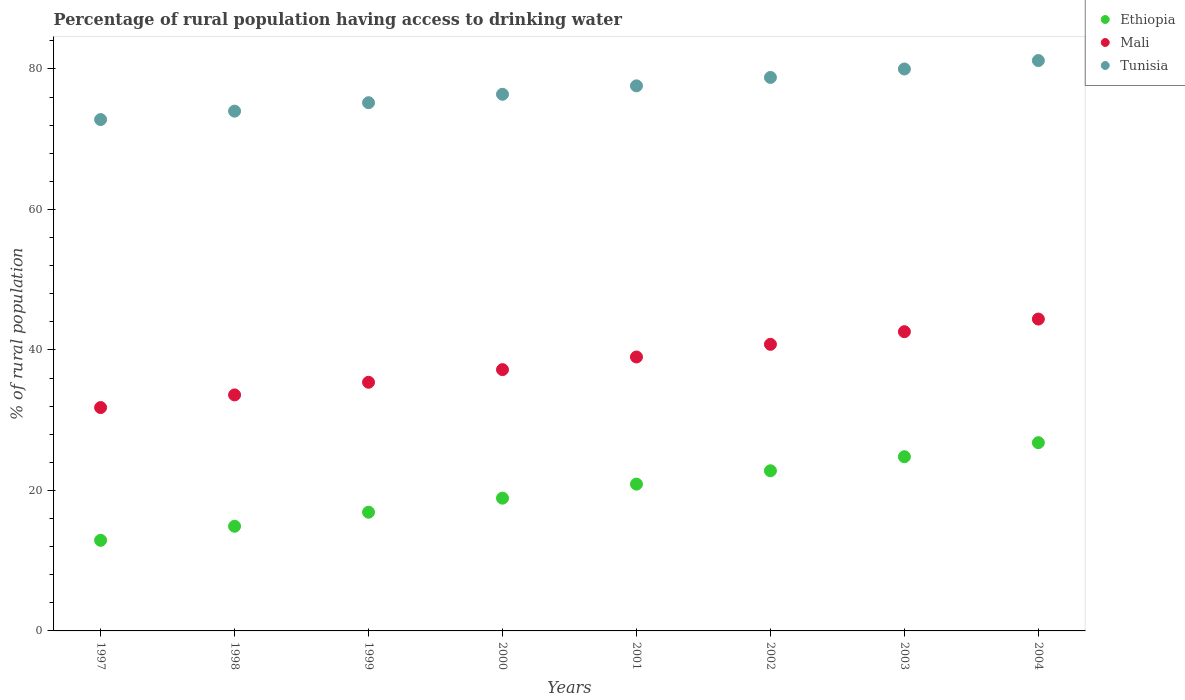Is the number of dotlines equal to the number of legend labels?
Your answer should be compact. Yes. Across all years, what is the maximum percentage of rural population having access to drinking water in Ethiopia?
Offer a very short reply. 26.8. In which year was the percentage of rural population having access to drinking water in Tunisia maximum?
Ensure brevity in your answer.  2004. What is the total percentage of rural population having access to drinking water in Ethiopia in the graph?
Keep it short and to the point. 158.9. What is the difference between the percentage of rural population having access to drinking water in Tunisia in 2001 and that in 2002?
Ensure brevity in your answer.  -1.2. What is the difference between the percentage of rural population having access to drinking water in Ethiopia in 2003 and the percentage of rural population having access to drinking water in Tunisia in 1999?
Make the answer very short. -50.4. What is the average percentage of rural population having access to drinking water in Ethiopia per year?
Your answer should be very brief. 19.86. In the year 2000, what is the difference between the percentage of rural population having access to drinking water in Tunisia and percentage of rural population having access to drinking water in Mali?
Make the answer very short. 39.2. What is the ratio of the percentage of rural population having access to drinking water in Mali in 1997 to that in 2002?
Offer a very short reply. 0.78. Is the difference between the percentage of rural population having access to drinking water in Tunisia in 1997 and 2002 greater than the difference between the percentage of rural population having access to drinking water in Mali in 1997 and 2002?
Keep it short and to the point. Yes. What is the difference between the highest and the second highest percentage of rural population having access to drinking water in Mali?
Offer a terse response. 1.8. What is the difference between the highest and the lowest percentage of rural population having access to drinking water in Mali?
Your answer should be compact. 12.6. Is it the case that in every year, the sum of the percentage of rural population having access to drinking water in Ethiopia and percentage of rural population having access to drinking water in Mali  is greater than the percentage of rural population having access to drinking water in Tunisia?
Your answer should be very brief. No. Is the percentage of rural population having access to drinking water in Tunisia strictly less than the percentage of rural population having access to drinking water in Mali over the years?
Ensure brevity in your answer.  No. How many dotlines are there?
Keep it short and to the point. 3. Does the graph contain any zero values?
Offer a terse response. No. Where does the legend appear in the graph?
Provide a short and direct response. Top right. What is the title of the graph?
Your answer should be compact. Percentage of rural population having access to drinking water. What is the label or title of the X-axis?
Ensure brevity in your answer.  Years. What is the label or title of the Y-axis?
Keep it short and to the point. % of rural population. What is the % of rural population in Ethiopia in 1997?
Offer a terse response. 12.9. What is the % of rural population in Mali in 1997?
Offer a very short reply. 31.8. What is the % of rural population of Tunisia in 1997?
Ensure brevity in your answer.  72.8. What is the % of rural population of Ethiopia in 1998?
Provide a succinct answer. 14.9. What is the % of rural population of Mali in 1998?
Provide a succinct answer. 33.6. What is the % of rural population of Tunisia in 1998?
Offer a very short reply. 74. What is the % of rural population of Ethiopia in 1999?
Provide a short and direct response. 16.9. What is the % of rural population of Mali in 1999?
Your response must be concise. 35.4. What is the % of rural population of Tunisia in 1999?
Keep it short and to the point. 75.2. What is the % of rural population in Mali in 2000?
Your answer should be compact. 37.2. What is the % of rural population of Tunisia in 2000?
Provide a succinct answer. 76.4. What is the % of rural population in Ethiopia in 2001?
Provide a short and direct response. 20.9. What is the % of rural population of Mali in 2001?
Ensure brevity in your answer.  39. What is the % of rural population of Tunisia in 2001?
Your answer should be compact. 77.6. What is the % of rural population of Ethiopia in 2002?
Ensure brevity in your answer.  22.8. What is the % of rural population in Mali in 2002?
Offer a very short reply. 40.8. What is the % of rural population of Tunisia in 2002?
Give a very brief answer. 78.8. What is the % of rural population in Ethiopia in 2003?
Provide a succinct answer. 24.8. What is the % of rural population of Mali in 2003?
Give a very brief answer. 42.6. What is the % of rural population of Tunisia in 2003?
Your response must be concise. 80. What is the % of rural population of Ethiopia in 2004?
Your response must be concise. 26.8. What is the % of rural population in Mali in 2004?
Give a very brief answer. 44.4. What is the % of rural population in Tunisia in 2004?
Keep it short and to the point. 81.2. Across all years, what is the maximum % of rural population in Ethiopia?
Your answer should be very brief. 26.8. Across all years, what is the maximum % of rural population of Mali?
Provide a short and direct response. 44.4. Across all years, what is the maximum % of rural population of Tunisia?
Give a very brief answer. 81.2. Across all years, what is the minimum % of rural population of Ethiopia?
Offer a very short reply. 12.9. Across all years, what is the minimum % of rural population of Mali?
Offer a terse response. 31.8. Across all years, what is the minimum % of rural population in Tunisia?
Ensure brevity in your answer.  72.8. What is the total % of rural population of Ethiopia in the graph?
Give a very brief answer. 158.9. What is the total % of rural population in Mali in the graph?
Make the answer very short. 304.8. What is the total % of rural population of Tunisia in the graph?
Your answer should be compact. 616. What is the difference between the % of rural population in Tunisia in 1997 and that in 1998?
Your response must be concise. -1.2. What is the difference between the % of rural population in Ethiopia in 1997 and that in 1999?
Your answer should be very brief. -4. What is the difference between the % of rural population of Ethiopia in 1997 and that in 2000?
Make the answer very short. -6. What is the difference between the % of rural population in Tunisia in 1997 and that in 2000?
Your answer should be very brief. -3.6. What is the difference between the % of rural population of Ethiopia in 1997 and that in 2001?
Your answer should be compact. -8. What is the difference between the % of rural population of Ethiopia in 1997 and that in 2002?
Keep it short and to the point. -9.9. What is the difference between the % of rural population in Tunisia in 1997 and that in 2002?
Provide a succinct answer. -6. What is the difference between the % of rural population of Mali in 1997 and that in 2003?
Your answer should be compact. -10.8. What is the difference between the % of rural population of Tunisia in 1997 and that in 2003?
Your response must be concise. -7.2. What is the difference between the % of rural population of Ethiopia in 1997 and that in 2004?
Your answer should be compact. -13.9. What is the difference between the % of rural population of Ethiopia in 1998 and that in 1999?
Offer a very short reply. -2. What is the difference between the % of rural population of Mali in 1998 and that in 1999?
Offer a terse response. -1.8. What is the difference between the % of rural population in Mali in 1998 and that in 2000?
Offer a terse response. -3.6. What is the difference between the % of rural population in Ethiopia in 1998 and that in 2001?
Keep it short and to the point. -6. What is the difference between the % of rural population in Mali in 1998 and that in 2001?
Your answer should be compact. -5.4. What is the difference between the % of rural population in Ethiopia in 1998 and that in 2002?
Your response must be concise. -7.9. What is the difference between the % of rural population in Mali in 1998 and that in 2002?
Your response must be concise. -7.2. What is the difference between the % of rural population of Mali in 1998 and that in 2003?
Your answer should be very brief. -9. What is the difference between the % of rural population in Tunisia in 1998 and that in 2004?
Make the answer very short. -7.2. What is the difference between the % of rural population of Ethiopia in 1999 and that in 2000?
Keep it short and to the point. -2. What is the difference between the % of rural population of Mali in 1999 and that in 2000?
Offer a terse response. -1.8. What is the difference between the % of rural population in Ethiopia in 1999 and that in 2001?
Your answer should be very brief. -4. What is the difference between the % of rural population of Tunisia in 1999 and that in 2002?
Offer a very short reply. -3.6. What is the difference between the % of rural population of Ethiopia in 1999 and that in 2003?
Provide a succinct answer. -7.9. What is the difference between the % of rural population of Mali in 1999 and that in 2003?
Give a very brief answer. -7.2. What is the difference between the % of rural population in Ethiopia in 2000 and that in 2001?
Ensure brevity in your answer.  -2. What is the difference between the % of rural population of Mali in 2000 and that in 2001?
Your answer should be very brief. -1.8. What is the difference between the % of rural population in Tunisia in 2000 and that in 2001?
Ensure brevity in your answer.  -1.2. What is the difference between the % of rural population in Ethiopia in 2000 and that in 2002?
Provide a short and direct response. -3.9. What is the difference between the % of rural population of Tunisia in 2000 and that in 2002?
Your answer should be very brief. -2.4. What is the difference between the % of rural population of Mali in 2000 and that in 2003?
Your answer should be very brief. -5.4. What is the difference between the % of rural population of Mali in 2000 and that in 2004?
Your response must be concise. -7.2. What is the difference between the % of rural population of Mali in 2001 and that in 2002?
Keep it short and to the point. -1.8. What is the difference between the % of rural population in Tunisia in 2001 and that in 2002?
Ensure brevity in your answer.  -1.2. What is the difference between the % of rural population of Mali in 2001 and that in 2003?
Make the answer very short. -3.6. What is the difference between the % of rural population in Tunisia in 2001 and that in 2003?
Your response must be concise. -2.4. What is the difference between the % of rural population in Ethiopia in 2001 and that in 2004?
Your response must be concise. -5.9. What is the difference between the % of rural population in Mali in 2001 and that in 2004?
Make the answer very short. -5.4. What is the difference between the % of rural population of Ethiopia in 2002 and that in 2003?
Provide a short and direct response. -2. What is the difference between the % of rural population of Tunisia in 2002 and that in 2003?
Keep it short and to the point. -1.2. What is the difference between the % of rural population of Mali in 2002 and that in 2004?
Provide a succinct answer. -3.6. What is the difference between the % of rural population of Mali in 2003 and that in 2004?
Your response must be concise. -1.8. What is the difference between the % of rural population of Tunisia in 2003 and that in 2004?
Keep it short and to the point. -1.2. What is the difference between the % of rural population of Ethiopia in 1997 and the % of rural population of Mali in 1998?
Make the answer very short. -20.7. What is the difference between the % of rural population of Ethiopia in 1997 and the % of rural population of Tunisia in 1998?
Ensure brevity in your answer.  -61.1. What is the difference between the % of rural population in Mali in 1997 and the % of rural population in Tunisia in 1998?
Your answer should be very brief. -42.2. What is the difference between the % of rural population in Ethiopia in 1997 and the % of rural population in Mali in 1999?
Ensure brevity in your answer.  -22.5. What is the difference between the % of rural population in Ethiopia in 1997 and the % of rural population in Tunisia in 1999?
Provide a short and direct response. -62.3. What is the difference between the % of rural population of Mali in 1997 and the % of rural population of Tunisia in 1999?
Provide a short and direct response. -43.4. What is the difference between the % of rural population of Ethiopia in 1997 and the % of rural population of Mali in 2000?
Provide a succinct answer. -24.3. What is the difference between the % of rural population in Ethiopia in 1997 and the % of rural population in Tunisia in 2000?
Keep it short and to the point. -63.5. What is the difference between the % of rural population of Mali in 1997 and the % of rural population of Tunisia in 2000?
Your answer should be very brief. -44.6. What is the difference between the % of rural population of Ethiopia in 1997 and the % of rural population of Mali in 2001?
Your answer should be very brief. -26.1. What is the difference between the % of rural population of Ethiopia in 1997 and the % of rural population of Tunisia in 2001?
Offer a terse response. -64.7. What is the difference between the % of rural population of Mali in 1997 and the % of rural population of Tunisia in 2001?
Your answer should be very brief. -45.8. What is the difference between the % of rural population in Ethiopia in 1997 and the % of rural population in Mali in 2002?
Give a very brief answer. -27.9. What is the difference between the % of rural population in Ethiopia in 1997 and the % of rural population in Tunisia in 2002?
Keep it short and to the point. -65.9. What is the difference between the % of rural population in Mali in 1997 and the % of rural population in Tunisia in 2002?
Give a very brief answer. -47. What is the difference between the % of rural population of Ethiopia in 1997 and the % of rural population of Mali in 2003?
Make the answer very short. -29.7. What is the difference between the % of rural population of Ethiopia in 1997 and the % of rural population of Tunisia in 2003?
Offer a terse response. -67.1. What is the difference between the % of rural population of Mali in 1997 and the % of rural population of Tunisia in 2003?
Offer a very short reply. -48.2. What is the difference between the % of rural population in Ethiopia in 1997 and the % of rural population in Mali in 2004?
Give a very brief answer. -31.5. What is the difference between the % of rural population of Ethiopia in 1997 and the % of rural population of Tunisia in 2004?
Keep it short and to the point. -68.3. What is the difference between the % of rural population in Mali in 1997 and the % of rural population in Tunisia in 2004?
Your answer should be compact. -49.4. What is the difference between the % of rural population in Ethiopia in 1998 and the % of rural population in Mali in 1999?
Keep it short and to the point. -20.5. What is the difference between the % of rural population in Ethiopia in 1998 and the % of rural population in Tunisia in 1999?
Your response must be concise. -60.3. What is the difference between the % of rural population in Mali in 1998 and the % of rural population in Tunisia in 1999?
Keep it short and to the point. -41.6. What is the difference between the % of rural population of Ethiopia in 1998 and the % of rural population of Mali in 2000?
Your answer should be compact. -22.3. What is the difference between the % of rural population of Ethiopia in 1998 and the % of rural population of Tunisia in 2000?
Your response must be concise. -61.5. What is the difference between the % of rural population in Mali in 1998 and the % of rural population in Tunisia in 2000?
Offer a very short reply. -42.8. What is the difference between the % of rural population in Ethiopia in 1998 and the % of rural population in Mali in 2001?
Make the answer very short. -24.1. What is the difference between the % of rural population in Ethiopia in 1998 and the % of rural population in Tunisia in 2001?
Provide a succinct answer. -62.7. What is the difference between the % of rural population of Mali in 1998 and the % of rural population of Tunisia in 2001?
Make the answer very short. -44. What is the difference between the % of rural population in Ethiopia in 1998 and the % of rural population in Mali in 2002?
Your answer should be compact. -25.9. What is the difference between the % of rural population in Ethiopia in 1998 and the % of rural population in Tunisia in 2002?
Provide a succinct answer. -63.9. What is the difference between the % of rural population in Mali in 1998 and the % of rural population in Tunisia in 2002?
Provide a succinct answer. -45.2. What is the difference between the % of rural population of Ethiopia in 1998 and the % of rural population of Mali in 2003?
Offer a terse response. -27.7. What is the difference between the % of rural population in Ethiopia in 1998 and the % of rural population in Tunisia in 2003?
Your answer should be very brief. -65.1. What is the difference between the % of rural population in Mali in 1998 and the % of rural population in Tunisia in 2003?
Offer a very short reply. -46.4. What is the difference between the % of rural population of Ethiopia in 1998 and the % of rural population of Mali in 2004?
Offer a terse response. -29.5. What is the difference between the % of rural population of Ethiopia in 1998 and the % of rural population of Tunisia in 2004?
Your response must be concise. -66.3. What is the difference between the % of rural population of Mali in 1998 and the % of rural population of Tunisia in 2004?
Your response must be concise. -47.6. What is the difference between the % of rural population of Ethiopia in 1999 and the % of rural population of Mali in 2000?
Keep it short and to the point. -20.3. What is the difference between the % of rural population of Ethiopia in 1999 and the % of rural population of Tunisia in 2000?
Offer a terse response. -59.5. What is the difference between the % of rural population of Mali in 1999 and the % of rural population of Tunisia in 2000?
Provide a succinct answer. -41. What is the difference between the % of rural population in Ethiopia in 1999 and the % of rural population in Mali in 2001?
Ensure brevity in your answer.  -22.1. What is the difference between the % of rural population in Ethiopia in 1999 and the % of rural population in Tunisia in 2001?
Your answer should be compact. -60.7. What is the difference between the % of rural population of Mali in 1999 and the % of rural population of Tunisia in 2001?
Provide a succinct answer. -42.2. What is the difference between the % of rural population in Ethiopia in 1999 and the % of rural population in Mali in 2002?
Your answer should be very brief. -23.9. What is the difference between the % of rural population of Ethiopia in 1999 and the % of rural population of Tunisia in 2002?
Your answer should be compact. -61.9. What is the difference between the % of rural population in Mali in 1999 and the % of rural population in Tunisia in 2002?
Offer a very short reply. -43.4. What is the difference between the % of rural population in Ethiopia in 1999 and the % of rural population in Mali in 2003?
Offer a very short reply. -25.7. What is the difference between the % of rural population of Ethiopia in 1999 and the % of rural population of Tunisia in 2003?
Provide a succinct answer. -63.1. What is the difference between the % of rural population in Mali in 1999 and the % of rural population in Tunisia in 2003?
Your answer should be compact. -44.6. What is the difference between the % of rural population of Ethiopia in 1999 and the % of rural population of Mali in 2004?
Offer a very short reply. -27.5. What is the difference between the % of rural population of Ethiopia in 1999 and the % of rural population of Tunisia in 2004?
Offer a terse response. -64.3. What is the difference between the % of rural population of Mali in 1999 and the % of rural population of Tunisia in 2004?
Provide a short and direct response. -45.8. What is the difference between the % of rural population in Ethiopia in 2000 and the % of rural population in Mali in 2001?
Offer a very short reply. -20.1. What is the difference between the % of rural population of Ethiopia in 2000 and the % of rural population of Tunisia in 2001?
Offer a very short reply. -58.7. What is the difference between the % of rural population of Mali in 2000 and the % of rural population of Tunisia in 2001?
Your answer should be compact. -40.4. What is the difference between the % of rural population of Ethiopia in 2000 and the % of rural population of Mali in 2002?
Your answer should be very brief. -21.9. What is the difference between the % of rural population of Ethiopia in 2000 and the % of rural population of Tunisia in 2002?
Provide a succinct answer. -59.9. What is the difference between the % of rural population of Mali in 2000 and the % of rural population of Tunisia in 2002?
Offer a terse response. -41.6. What is the difference between the % of rural population of Ethiopia in 2000 and the % of rural population of Mali in 2003?
Your answer should be compact. -23.7. What is the difference between the % of rural population in Ethiopia in 2000 and the % of rural population in Tunisia in 2003?
Offer a very short reply. -61.1. What is the difference between the % of rural population of Mali in 2000 and the % of rural population of Tunisia in 2003?
Provide a succinct answer. -42.8. What is the difference between the % of rural population in Ethiopia in 2000 and the % of rural population in Mali in 2004?
Offer a terse response. -25.5. What is the difference between the % of rural population of Ethiopia in 2000 and the % of rural population of Tunisia in 2004?
Give a very brief answer. -62.3. What is the difference between the % of rural population in Mali in 2000 and the % of rural population in Tunisia in 2004?
Give a very brief answer. -44. What is the difference between the % of rural population of Ethiopia in 2001 and the % of rural population of Mali in 2002?
Provide a succinct answer. -19.9. What is the difference between the % of rural population of Ethiopia in 2001 and the % of rural population of Tunisia in 2002?
Keep it short and to the point. -57.9. What is the difference between the % of rural population in Mali in 2001 and the % of rural population in Tunisia in 2002?
Keep it short and to the point. -39.8. What is the difference between the % of rural population of Ethiopia in 2001 and the % of rural population of Mali in 2003?
Give a very brief answer. -21.7. What is the difference between the % of rural population in Ethiopia in 2001 and the % of rural population in Tunisia in 2003?
Offer a terse response. -59.1. What is the difference between the % of rural population in Mali in 2001 and the % of rural population in Tunisia in 2003?
Offer a terse response. -41. What is the difference between the % of rural population in Ethiopia in 2001 and the % of rural population in Mali in 2004?
Give a very brief answer. -23.5. What is the difference between the % of rural population in Ethiopia in 2001 and the % of rural population in Tunisia in 2004?
Provide a succinct answer. -60.3. What is the difference between the % of rural population of Mali in 2001 and the % of rural population of Tunisia in 2004?
Your response must be concise. -42.2. What is the difference between the % of rural population in Ethiopia in 2002 and the % of rural population in Mali in 2003?
Offer a very short reply. -19.8. What is the difference between the % of rural population in Ethiopia in 2002 and the % of rural population in Tunisia in 2003?
Your answer should be compact. -57.2. What is the difference between the % of rural population in Mali in 2002 and the % of rural population in Tunisia in 2003?
Your answer should be compact. -39.2. What is the difference between the % of rural population of Ethiopia in 2002 and the % of rural population of Mali in 2004?
Offer a terse response. -21.6. What is the difference between the % of rural population in Ethiopia in 2002 and the % of rural population in Tunisia in 2004?
Your response must be concise. -58.4. What is the difference between the % of rural population in Mali in 2002 and the % of rural population in Tunisia in 2004?
Your answer should be compact. -40.4. What is the difference between the % of rural population in Ethiopia in 2003 and the % of rural population in Mali in 2004?
Your answer should be compact. -19.6. What is the difference between the % of rural population in Ethiopia in 2003 and the % of rural population in Tunisia in 2004?
Give a very brief answer. -56.4. What is the difference between the % of rural population in Mali in 2003 and the % of rural population in Tunisia in 2004?
Keep it short and to the point. -38.6. What is the average % of rural population of Ethiopia per year?
Make the answer very short. 19.86. What is the average % of rural population in Mali per year?
Provide a succinct answer. 38.1. What is the average % of rural population of Tunisia per year?
Offer a terse response. 77. In the year 1997, what is the difference between the % of rural population of Ethiopia and % of rural population of Mali?
Keep it short and to the point. -18.9. In the year 1997, what is the difference between the % of rural population in Ethiopia and % of rural population in Tunisia?
Give a very brief answer. -59.9. In the year 1997, what is the difference between the % of rural population in Mali and % of rural population in Tunisia?
Your answer should be compact. -41. In the year 1998, what is the difference between the % of rural population in Ethiopia and % of rural population in Mali?
Your answer should be compact. -18.7. In the year 1998, what is the difference between the % of rural population of Ethiopia and % of rural population of Tunisia?
Provide a succinct answer. -59.1. In the year 1998, what is the difference between the % of rural population of Mali and % of rural population of Tunisia?
Make the answer very short. -40.4. In the year 1999, what is the difference between the % of rural population in Ethiopia and % of rural population in Mali?
Offer a very short reply. -18.5. In the year 1999, what is the difference between the % of rural population of Ethiopia and % of rural population of Tunisia?
Your answer should be compact. -58.3. In the year 1999, what is the difference between the % of rural population of Mali and % of rural population of Tunisia?
Make the answer very short. -39.8. In the year 2000, what is the difference between the % of rural population in Ethiopia and % of rural population in Mali?
Provide a succinct answer. -18.3. In the year 2000, what is the difference between the % of rural population in Ethiopia and % of rural population in Tunisia?
Provide a succinct answer. -57.5. In the year 2000, what is the difference between the % of rural population in Mali and % of rural population in Tunisia?
Your response must be concise. -39.2. In the year 2001, what is the difference between the % of rural population in Ethiopia and % of rural population in Mali?
Your answer should be compact. -18.1. In the year 2001, what is the difference between the % of rural population of Ethiopia and % of rural population of Tunisia?
Provide a succinct answer. -56.7. In the year 2001, what is the difference between the % of rural population of Mali and % of rural population of Tunisia?
Keep it short and to the point. -38.6. In the year 2002, what is the difference between the % of rural population in Ethiopia and % of rural population in Tunisia?
Offer a terse response. -56. In the year 2002, what is the difference between the % of rural population in Mali and % of rural population in Tunisia?
Ensure brevity in your answer.  -38. In the year 2003, what is the difference between the % of rural population in Ethiopia and % of rural population in Mali?
Your answer should be very brief. -17.8. In the year 2003, what is the difference between the % of rural population of Ethiopia and % of rural population of Tunisia?
Offer a terse response. -55.2. In the year 2003, what is the difference between the % of rural population of Mali and % of rural population of Tunisia?
Make the answer very short. -37.4. In the year 2004, what is the difference between the % of rural population in Ethiopia and % of rural population in Mali?
Ensure brevity in your answer.  -17.6. In the year 2004, what is the difference between the % of rural population of Ethiopia and % of rural population of Tunisia?
Keep it short and to the point. -54.4. In the year 2004, what is the difference between the % of rural population of Mali and % of rural population of Tunisia?
Keep it short and to the point. -36.8. What is the ratio of the % of rural population of Ethiopia in 1997 to that in 1998?
Offer a very short reply. 0.87. What is the ratio of the % of rural population of Mali in 1997 to that in 1998?
Offer a very short reply. 0.95. What is the ratio of the % of rural population of Tunisia in 1997 to that in 1998?
Give a very brief answer. 0.98. What is the ratio of the % of rural population of Ethiopia in 1997 to that in 1999?
Offer a terse response. 0.76. What is the ratio of the % of rural population of Mali in 1997 to that in 1999?
Keep it short and to the point. 0.9. What is the ratio of the % of rural population in Tunisia in 1997 to that in 1999?
Offer a terse response. 0.97. What is the ratio of the % of rural population in Ethiopia in 1997 to that in 2000?
Give a very brief answer. 0.68. What is the ratio of the % of rural population of Mali in 1997 to that in 2000?
Offer a terse response. 0.85. What is the ratio of the % of rural population in Tunisia in 1997 to that in 2000?
Offer a terse response. 0.95. What is the ratio of the % of rural population in Ethiopia in 1997 to that in 2001?
Provide a succinct answer. 0.62. What is the ratio of the % of rural population in Mali in 1997 to that in 2001?
Provide a succinct answer. 0.82. What is the ratio of the % of rural population in Tunisia in 1997 to that in 2001?
Provide a succinct answer. 0.94. What is the ratio of the % of rural population in Ethiopia in 1997 to that in 2002?
Your answer should be compact. 0.57. What is the ratio of the % of rural population of Mali in 1997 to that in 2002?
Ensure brevity in your answer.  0.78. What is the ratio of the % of rural population of Tunisia in 1997 to that in 2002?
Your answer should be compact. 0.92. What is the ratio of the % of rural population in Ethiopia in 1997 to that in 2003?
Provide a short and direct response. 0.52. What is the ratio of the % of rural population of Mali in 1997 to that in 2003?
Give a very brief answer. 0.75. What is the ratio of the % of rural population of Tunisia in 1997 to that in 2003?
Provide a short and direct response. 0.91. What is the ratio of the % of rural population of Ethiopia in 1997 to that in 2004?
Provide a short and direct response. 0.48. What is the ratio of the % of rural population in Mali in 1997 to that in 2004?
Your response must be concise. 0.72. What is the ratio of the % of rural population of Tunisia in 1997 to that in 2004?
Provide a succinct answer. 0.9. What is the ratio of the % of rural population in Ethiopia in 1998 to that in 1999?
Offer a very short reply. 0.88. What is the ratio of the % of rural population in Mali in 1998 to that in 1999?
Your response must be concise. 0.95. What is the ratio of the % of rural population of Ethiopia in 1998 to that in 2000?
Your answer should be very brief. 0.79. What is the ratio of the % of rural population of Mali in 1998 to that in 2000?
Your answer should be compact. 0.9. What is the ratio of the % of rural population of Tunisia in 1998 to that in 2000?
Offer a terse response. 0.97. What is the ratio of the % of rural population of Ethiopia in 1998 to that in 2001?
Your answer should be very brief. 0.71. What is the ratio of the % of rural population of Mali in 1998 to that in 2001?
Keep it short and to the point. 0.86. What is the ratio of the % of rural population of Tunisia in 1998 to that in 2001?
Offer a terse response. 0.95. What is the ratio of the % of rural population in Ethiopia in 1998 to that in 2002?
Your answer should be compact. 0.65. What is the ratio of the % of rural population in Mali in 1998 to that in 2002?
Give a very brief answer. 0.82. What is the ratio of the % of rural population in Tunisia in 1998 to that in 2002?
Keep it short and to the point. 0.94. What is the ratio of the % of rural population of Ethiopia in 1998 to that in 2003?
Provide a succinct answer. 0.6. What is the ratio of the % of rural population of Mali in 1998 to that in 2003?
Offer a very short reply. 0.79. What is the ratio of the % of rural population of Tunisia in 1998 to that in 2003?
Provide a succinct answer. 0.93. What is the ratio of the % of rural population in Ethiopia in 1998 to that in 2004?
Ensure brevity in your answer.  0.56. What is the ratio of the % of rural population of Mali in 1998 to that in 2004?
Provide a succinct answer. 0.76. What is the ratio of the % of rural population of Tunisia in 1998 to that in 2004?
Your answer should be very brief. 0.91. What is the ratio of the % of rural population of Ethiopia in 1999 to that in 2000?
Give a very brief answer. 0.89. What is the ratio of the % of rural population in Mali in 1999 to that in 2000?
Make the answer very short. 0.95. What is the ratio of the % of rural population of Tunisia in 1999 to that in 2000?
Offer a very short reply. 0.98. What is the ratio of the % of rural population of Ethiopia in 1999 to that in 2001?
Provide a short and direct response. 0.81. What is the ratio of the % of rural population of Mali in 1999 to that in 2001?
Give a very brief answer. 0.91. What is the ratio of the % of rural population in Tunisia in 1999 to that in 2001?
Provide a short and direct response. 0.97. What is the ratio of the % of rural population of Ethiopia in 1999 to that in 2002?
Make the answer very short. 0.74. What is the ratio of the % of rural population in Mali in 1999 to that in 2002?
Give a very brief answer. 0.87. What is the ratio of the % of rural population of Tunisia in 1999 to that in 2002?
Ensure brevity in your answer.  0.95. What is the ratio of the % of rural population of Ethiopia in 1999 to that in 2003?
Make the answer very short. 0.68. What is the ratio of the % of rural population in Mali in 1999 to that in 2003?
Offer a very short reply. 0.83. What is the ratio of the % of rural population in Ethiopia in 1999 to that in 2004?
Offer a very short reply. 0.63. What is the ratio of the % of rural population of Mali in 1999 to that in 2004?
Your answer should be compact. 0.8. What is the ratio of the % of rural population of Tunisia in 1999 to that in 2004?
Give a very brief answer. 0.93. What is the ratio of the % of rural population in Ethiopia in 2000 to that in 2001?
Your response must be concise. 0.9. What is the ratio of the % of rural population in Mali in 2000 to that in 2001?
Your response must be concise. 0.95. What is the ratio of the % of rural population in Tunisia in 2000 to that in 2001?
Provide a short and direct response. 0.98. What is the ratio of the % of rural population in Ethiopia in 2000 to that in 2002?
Provide a short and direct response. 0.83. What is the ratio of the % of rural population of Mali in 2000 to that in 2002?
Offer a very short reply. 0.91. What is the ratio of the % of rural population in Tunisia in 2000 to that in 2002?
Give a very brief answer. 0.97. What is the ratio of the % of rural population in Ethiopia in 2000 to that in 2003?
Offer a very short reply. 0.76. What is the ratio of the % of rural population of Mali in 2000 to that in 2003?
Keep it short and to the point. 0.87. What is the ratio of the % of rural population in Tunisia in 2000 to that in 2003?
Provide a short and direct response. 0.95. What is the ratio of the % of rural population in Ethiopia in 2000 to that in 2004?
Give a very brief answer. 0.71. What is the ratio of the % of rural population of Mali in 2000 to that in 2004?
Provide a succinct answer. 0.84. What is the ratio of the % of rural population in Tunisia in 2000 to that in 2004?
Provide a succinct answer. 0.94. What is the ratio of the % of rural population in Mali in 2001 to that in 2002?
Keep it short and to the point. 0.96. What is the ratio of the % of rural population of Ethiopia in 2001 to that in 2003?
Make the answer very short. 0.84. What is the ratio of the % of rural population in Mali in 2001 to that in 2003?
Ensure brevity in your answer.  0.92. What is the ratio of the % of rural population of Ethiopia in 2001 to that in 2004?
Make the answer very short. 0.78. What is the ratio of the % of rural population in Mali in 2001 to that in 2004?
Offer a terse response. 0.88. What is the ratio of the % of rural population in Tunisia in 2001 to that in 2004?
Your response must be concise. 0.96. What is the ratio of the % of rural population in Ethiopia in 2002 to that in 2003?
Ensure brevity in your answer.  0.92. What is the ratio of the % of rural population in Mali in 2002 to that in 2003?
Give a very brief answer. 0.96. What is the ratio of the % of rural population of Ethiopia in 2002 to that in 2004?
Offer a terse response. 0.85. What is the ratio of the % of rural population in Mali in 2002 to that in 2004?
Offer a very short reply. 0.92. What is the ratio of the % of rural population of Tunisia in 2002 to that in 2004?
Your answer should be very brief. 0.97. What is the ratio of the % of rural population of Ethiopia in 2003 to that in 2004?
Offer a terse response. 0.93. What is the ratio of the % of rural population in Mali in 2003 to that in 2004?
Offer a terse response. 0.96. What is the ratio of the % of rural population in Tunisia in 2003 to that in 2004?
Your response must be concise. 0.99. What is the difference between the highest and the second highest % of rural population in Mali?
Ensure brevity in your answer.  1.8. What is the difference between the highest and the second highest % of rural population of Tunisia?
Make the answer very short. 1.2. What is the difference between the highest and the lowest % of rural population in Ethiopia?
Offer a very short reply. 13.9. What is the difference between the highest and the lowest % of rural population in Mali?
Provide a short and direct response. 12.6. 